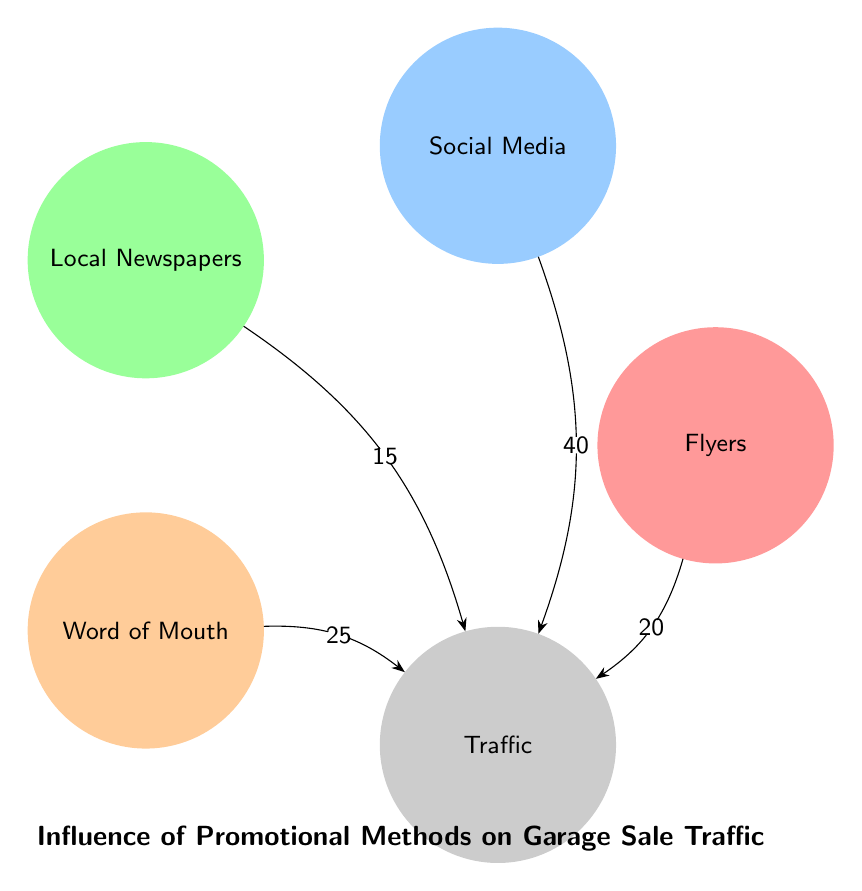What promotional method brings the most traffic? The diagram indicates that "Social Media" has the highest value of 40 influencing "Traffic."
Answer: Social Media How many nodes are in the diagram? The diagram has a total of 5 nodes: Flyers, Social Media, Local Newspapers, Word of Mouth, and Traffic.
Answer: 5 What is the value of "Flyers" in relation to "Traffic"? The value of the link between "Flyers" and "Traffic" is 20, indicating its influence on traffic.
Answer: 20 Which promotional method has the least influence on traffic? The link between "Local Newspapers" and "Traffic" shows the lowest value of 15, making it the least influential method.
Answer: Local Newspapers What is the total influence from all promotional methods combined? By adding the values (20 + 40 + 15 + 25), the total influence on traffic sums up to 100.
Answer: 100 Which two promotional methods contribute a combined total of 65 to traffic? The combined values of "Social Media" (40) and "Word of Mouth" (25) add to 65, identifying both as contributors.
Answer: Social Media and Word of Mouth How many edges are in the diagram? The diagram has 4 edges connecting the promotional methods to traffic, indicating direct relationships.
Answer: 4 Which promotional method contributes more than 20 to traffic? Both "Social Media" (40) and "Word of Mouth" (25) have values greater than 20, indicating higher contributions.
Answer: Social Media and Word of Mouth 